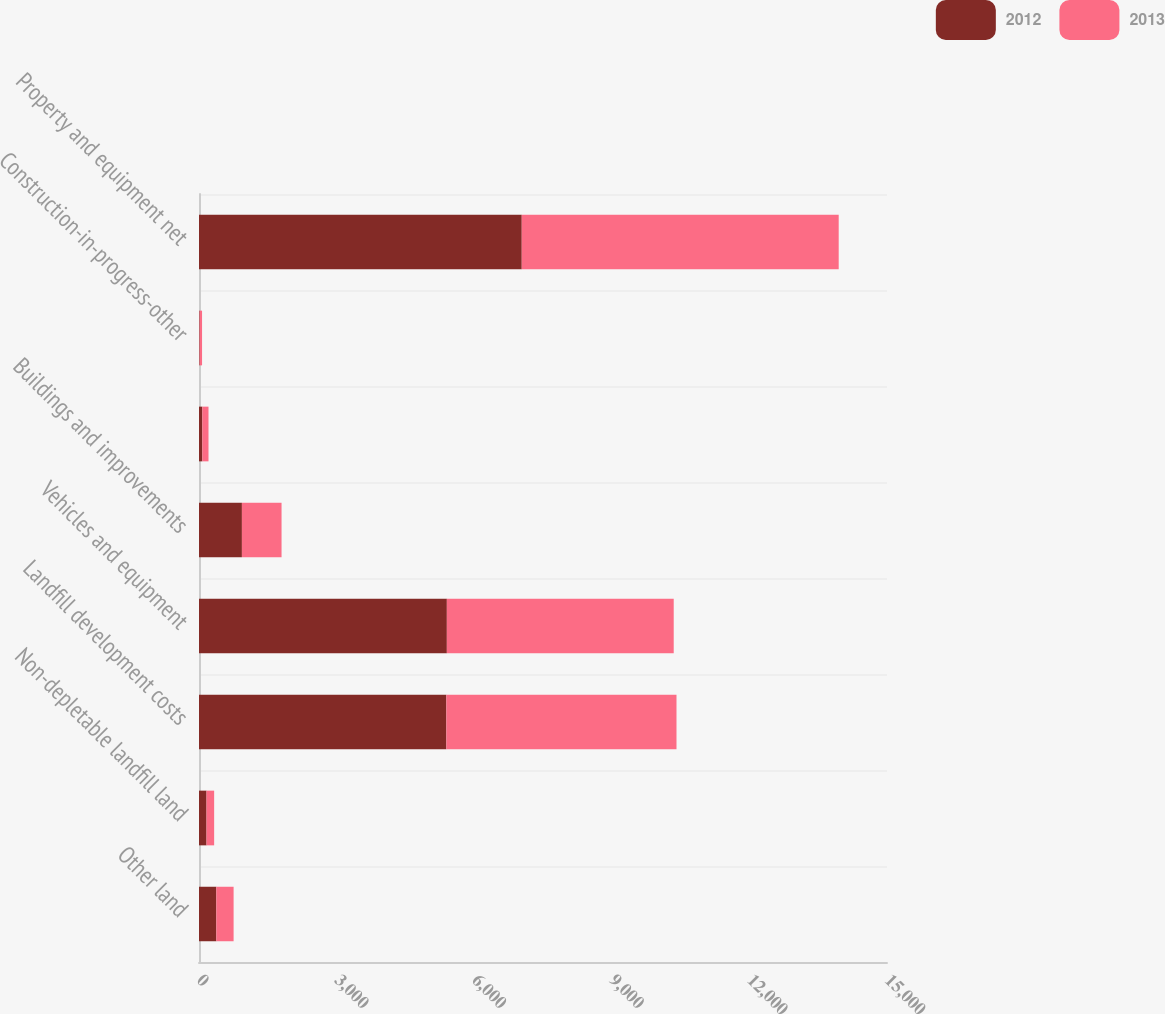Convert chart. <chart><loc_0><loc_0><loc_500><loc_500><stacked_bar_chart><ecel><fcel>Other land<fcel>Non-depletable landfill land<fcel>Landfill development costs<fcel>Vehicles and equipment<fcel>Buildings and improvements<fcel>Unnamed: 6<fcel>Construction-in-progress-other<fcel>Property and equipment net<nl><fcel>2012<fcel>377.6<fcel>164.2<fcel>5392.7<fcel>5403.7<fcel>935.6<fcel>72.5<fcel>13.3<fcel>7036.8<nl><fcel>2013<fcel>376.9<fcel>166<fcel>5018<fcel>4946.4<fcel>864.2<fcel>134.5<fcel>53.3<fcel>6910.3<nl></chart> 